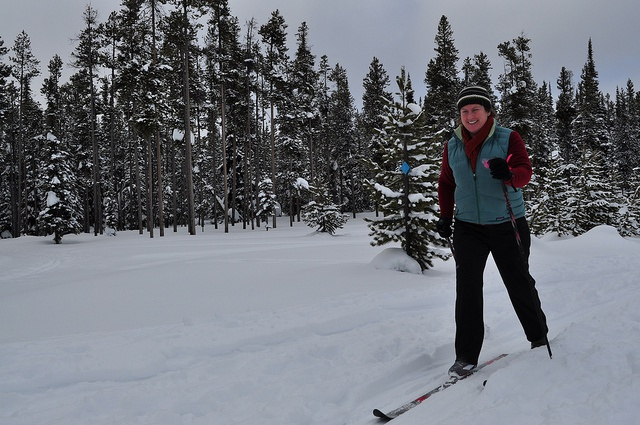Describe the objects in this image and their specific colors. I can see people in darkgray, black, blue, darkblue, and gray tones and skis in darkgray, gray, and black tones in this image. 